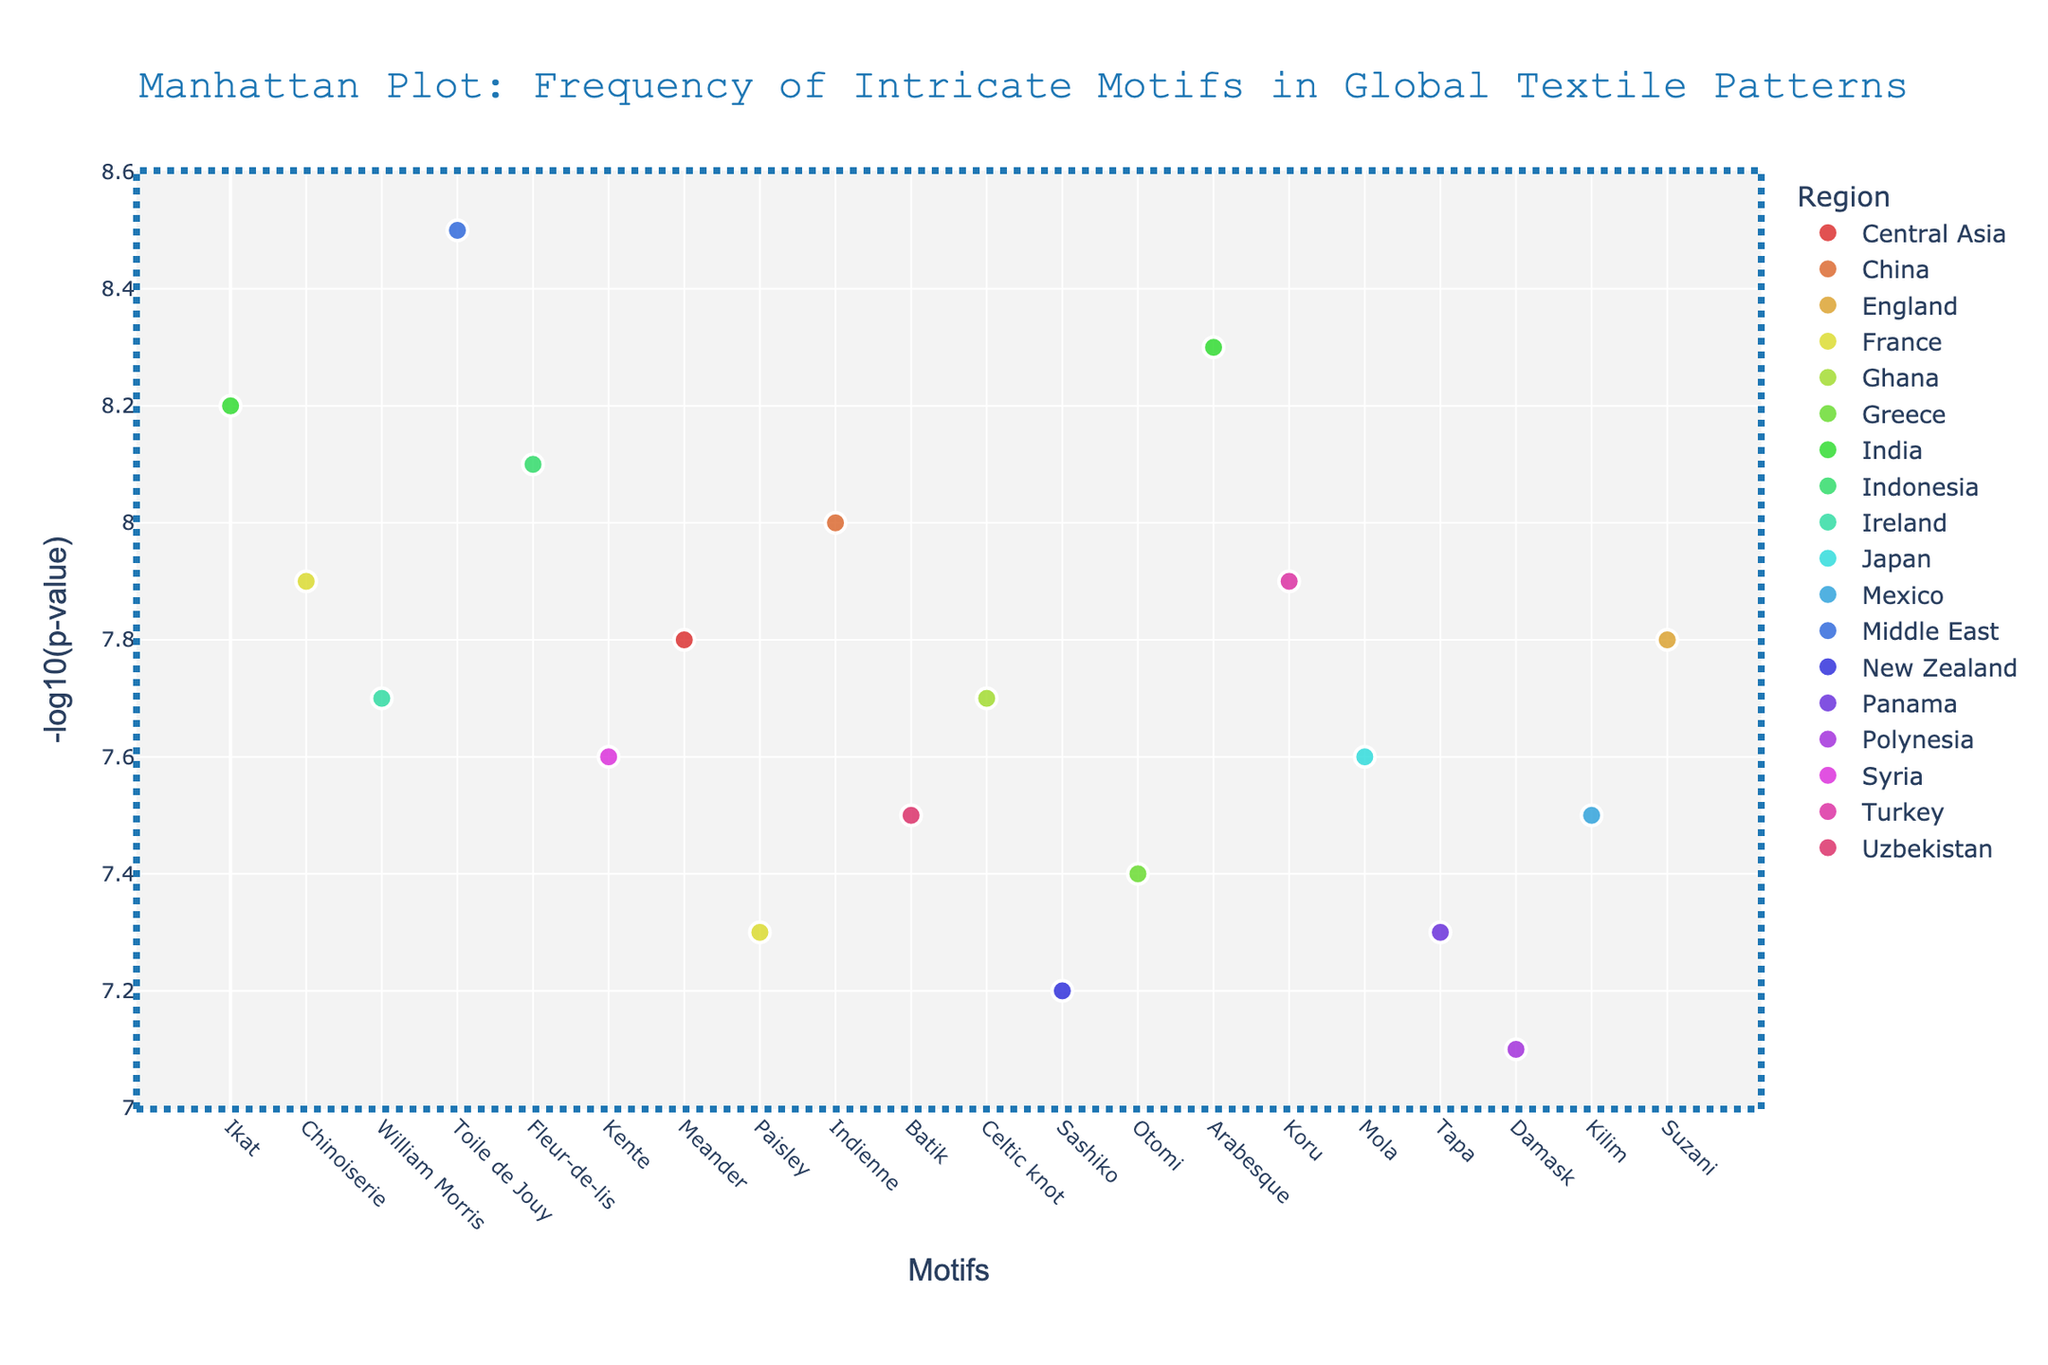what is the motif with the highest -log10(p-value)? Look at the y-axis for the highest data point. The tooltip shows the motif when you hover over the point.
Answer: Arabesque How many motifs are there in total? Count the total number of dots/data points in the plot.
Answer: 20 Which region has the motif with the second highest -log10(p-value)? Identify the second highest data point on the y-axis and check the tooltip for the region when you hover over it.
Answer: India What is the -log10(p-value) for the motif “Indienne”? Locate "Indienne" on the x-axis and refer to its y-axis value.
Answer: 8.3 Which regions have motifs with -log10(p-value) values less than 7.6? Look for data points below y-axis value of 7.6 and check the tooltips for respective regions.
Answer: France, New Zealand, Panama, Polynesia How many motifs have a -log10(p-value) greater than 8.0? Count all data points above the y-axis value of 8.0.
Answer: 5 Between motifs from France and India, which region has motifs with higher average -log10(p-value)? Calculate the mean of -log10(p-value) for motifs from France and India, then compare. (France: (7.9 + 7.3) / 2 = 7.6, India: (8.2 + 8.3) / 2 = 8.25)
Answer: India Which motif from Indonesia has one of the highest -log10(p-values)? Locate Indonesia on the plot and check the y-axis value for its representative motif.
Answer: Batik Is there any visible trend or pattern in the distribution of -log10(p-value) across different regions? Examine the spread and clustering of data points across all regions to identify any repeating trends or patterns.
Answer: No clear trend, regions are distributed What's the color used to represent motifs from the Middle East? Identify the region "Middle East" in the legend and notice the color used.
Answer: A shade of blue 